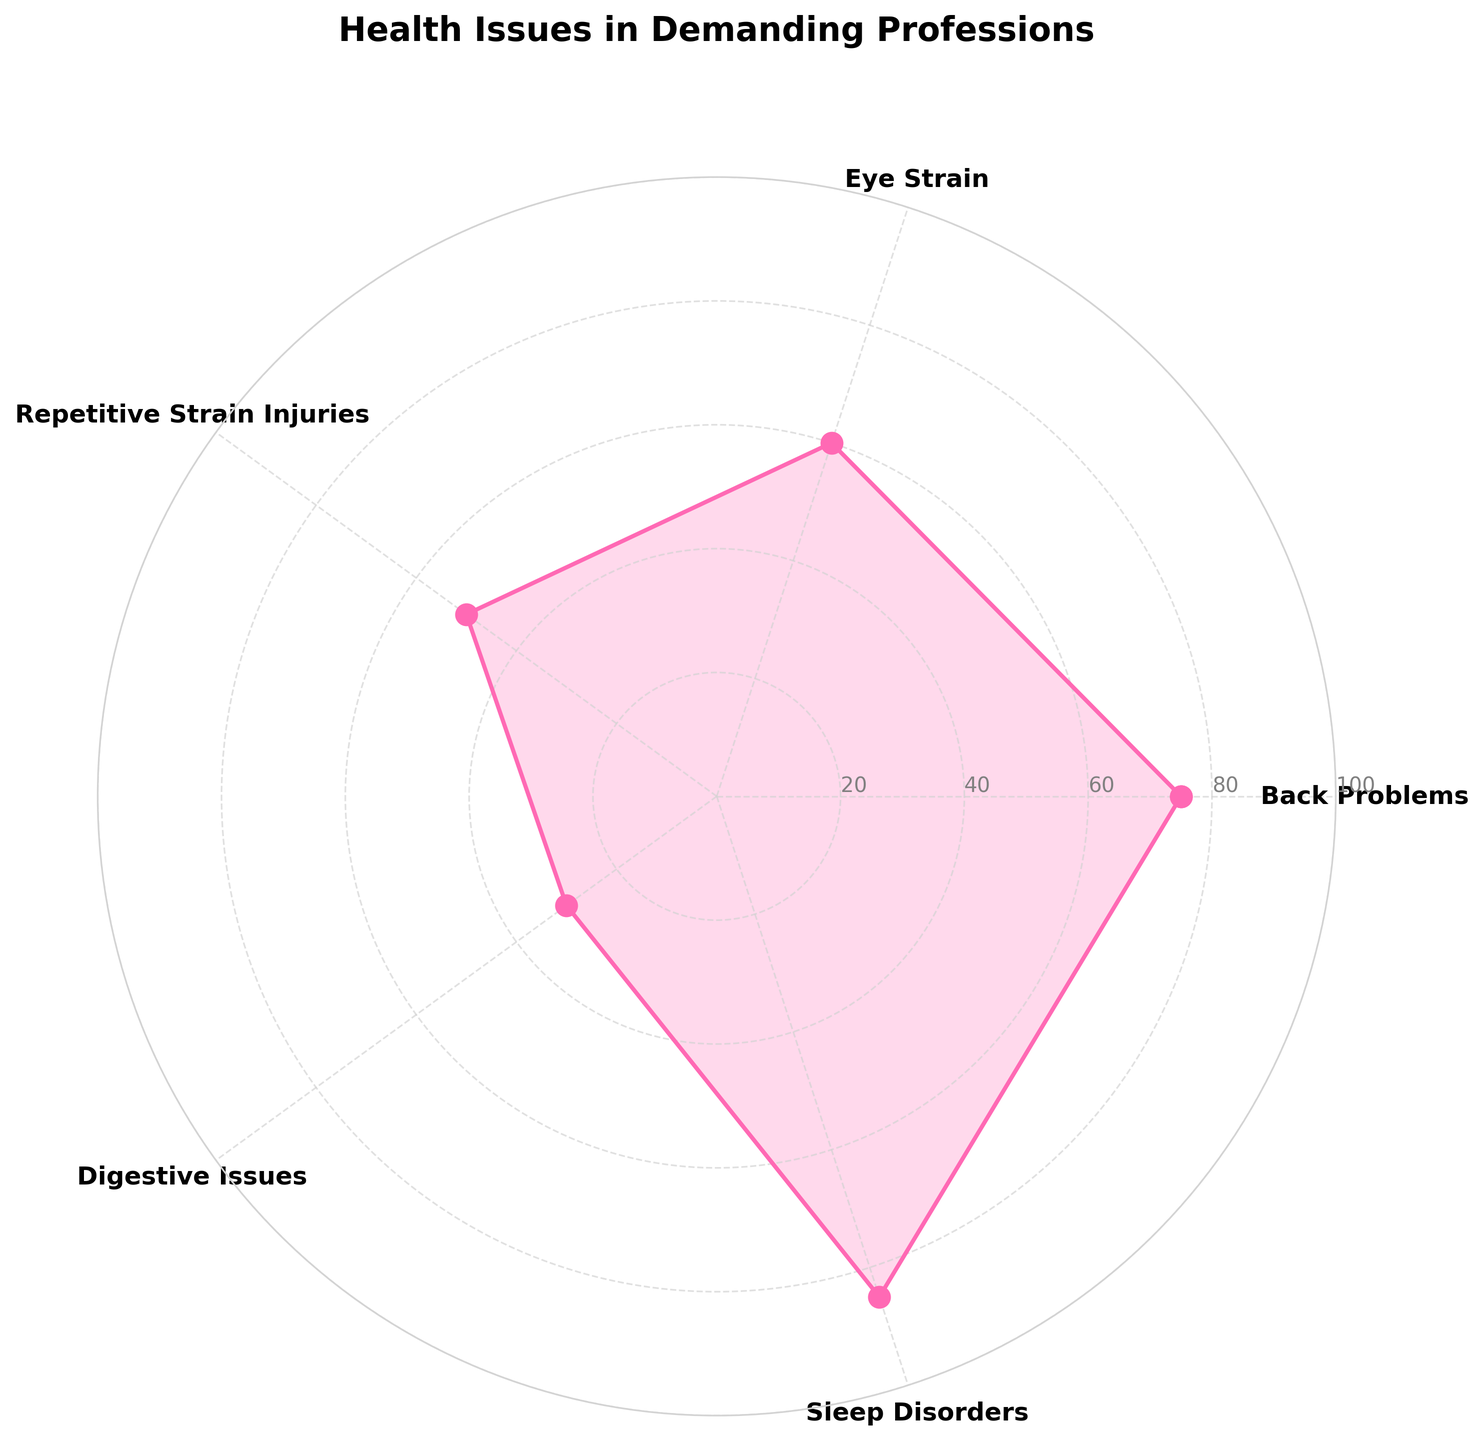What is the title of the chart? The title is located at the top of the chart and provides a brief description of what the data represents.
Answer: Health Issues in Demanding Professions How many categories of health issues are shown in the chart? The chart labels each segment with a health issue category. Counting the labels will give the total number of categories.
Answer: 5 What are the values for 'Back Problems' and 'Eye Strain'? Check the respective segments on the chart where 'Back Problems' and 'Eye Strain' are labeled, and look at their corresponding numerical values.
Answer: 75 and 60 Which health issue has the highest reported frequency? Look for the segment with the largest value in the chart and identify its category label.
Answer: Sleep Disorders What is the sum of the frequencies of 'Repetitive Strain Injuries' and 'Digestive Issues'? Locate the values for both 'Repetitive Strain Injuries' and 'Digestive Issues' and add them together: 50 + 30.
Answer: 80 Which health issue has the lowest reported frequency? Find the segment with the smallest value in the chart and identify its category label.
Answer: Digestive Issues Compare the frequencies of 'Sleep Disorders' and 'Eye Strain'. Which one is higher? Check the values for 'Sleep Disorders' and 'Eye Strain' and determine which one is greater: 85 > 60.
Answer: Sleep Disorders What is the average frequency of all reported health issues? Sum all the category values and then divide by the number of categories: (75 + 60 + 50 + 30 + 85) / 5 = 60
Answer: 60 Is there a significant difference between the highest and the lowest reported frequencies? Calculate the difference between the highest frequency (85 for 'Sleep Disorders') and the lowest frequency (30 for 'Digestive Issues'): 85 - 30.
Answer: Yes, the difference is 55 What angle does each category segment span if the chart is equally divided? Since the chart is equally divided into 5 categories and a full circle is 360 degrees, each category spans 360 / 5 = 72 degrees.
Answer: 72 degrees 